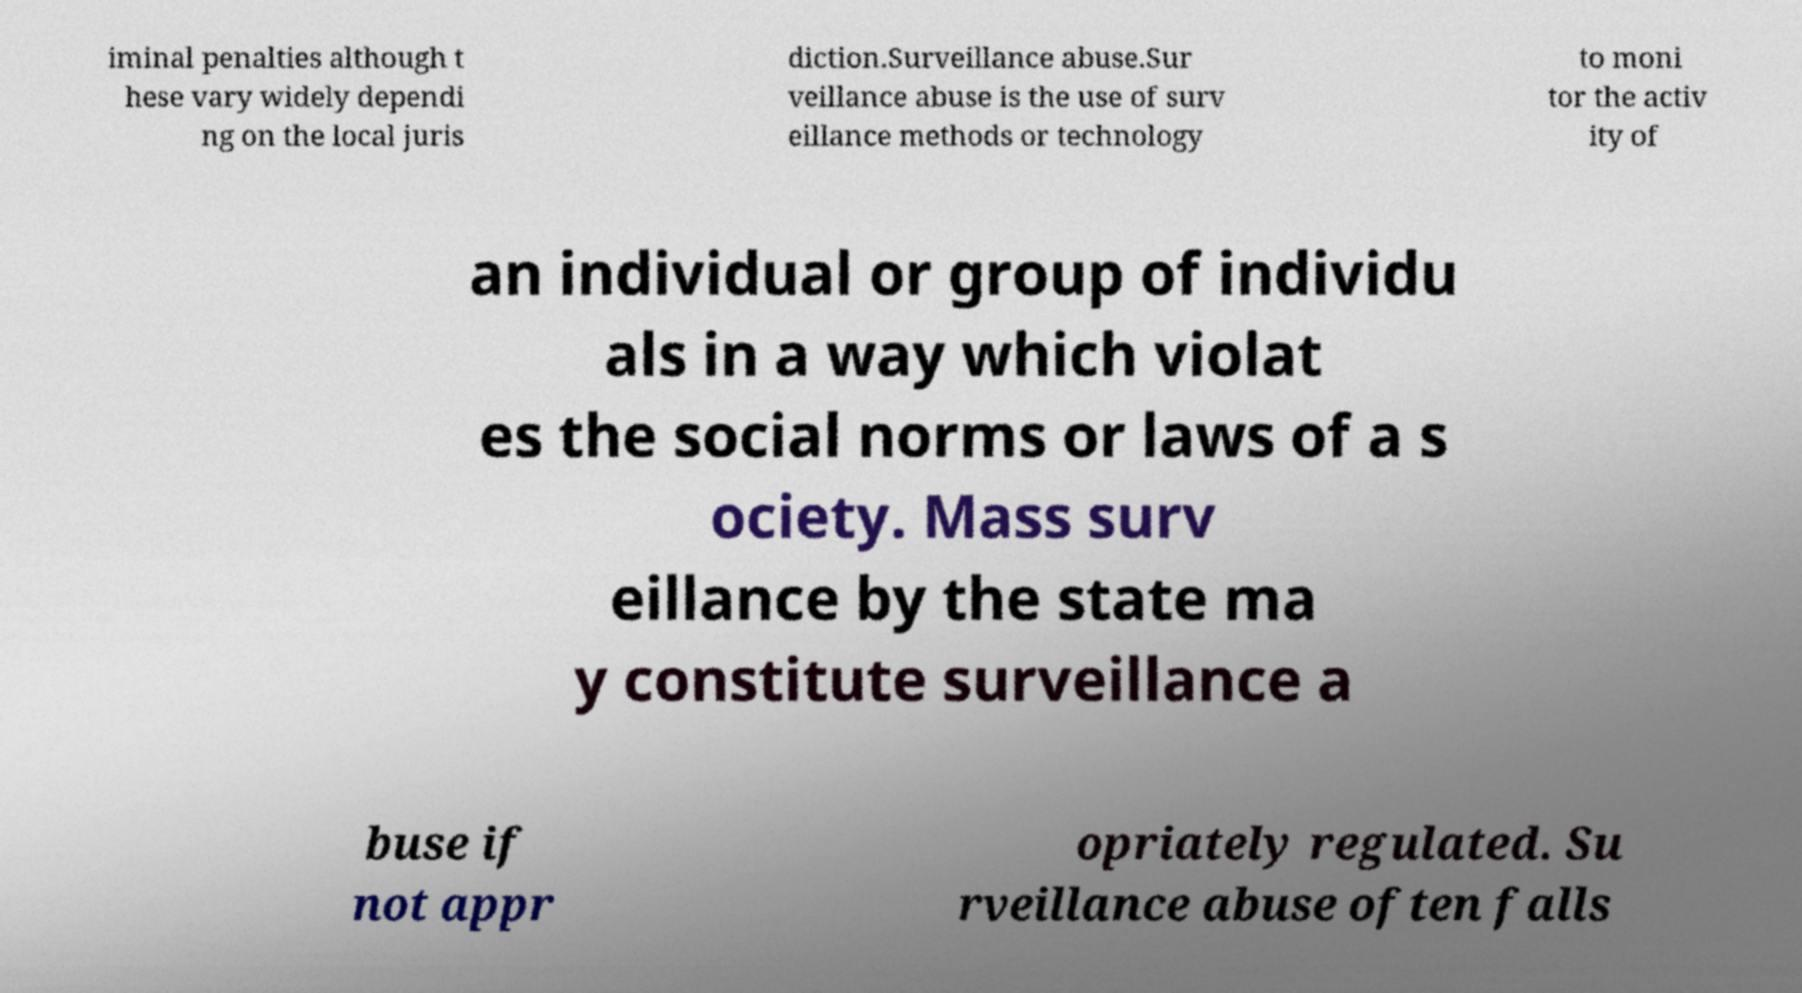Could you extract and type out the text from this image? iminal penalties although t hese vary widely dependi ng on the local juris diction.Surveillance abuse.Sur veillance abuse is the use of surv eillance methods or technology to moni tor the activ ity of an individual or group of individu als in a way which violat es the social norms or laws of a s ociety. Mass surv eillance by the state ma y constitute surveillance a buse if not appr opriately regulated. Su rveillance abuse often falls 